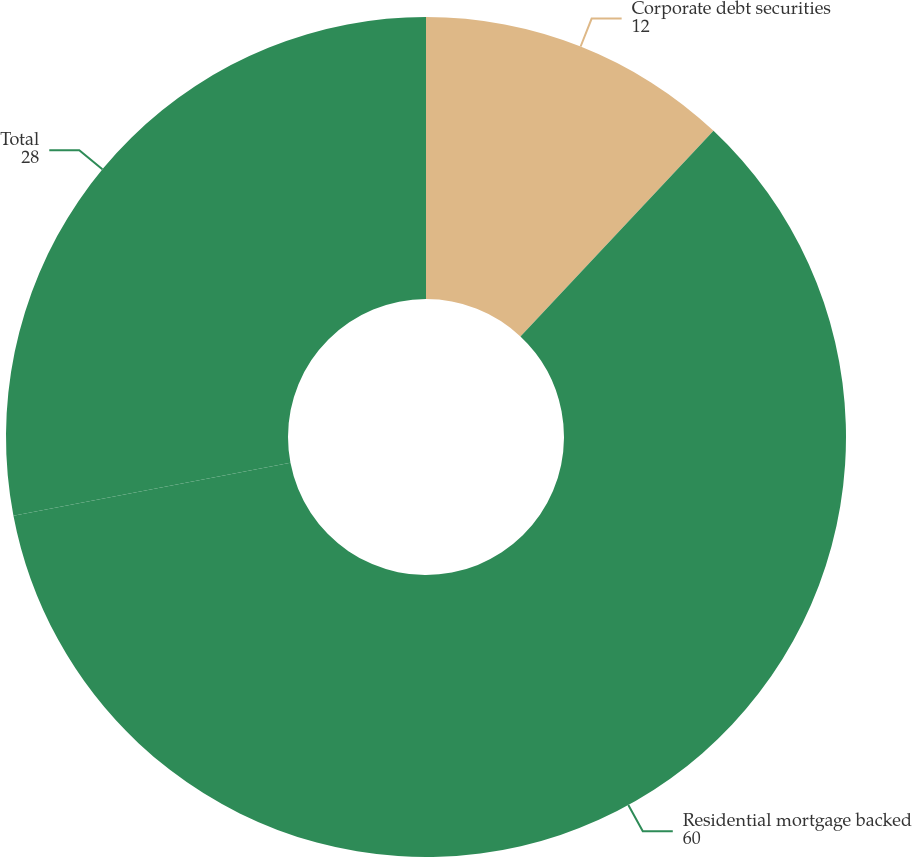Convert chart to OTSL. <chart><loc_0><loc_0><loc_500><loc_500><pie_chart><fcel>Corporate debt securities<fcel>Residential mortgage backed<fcel>Total<nl><fcel>12.0%<fcel>60.0%<fcel>28.0%<nl></chart> 